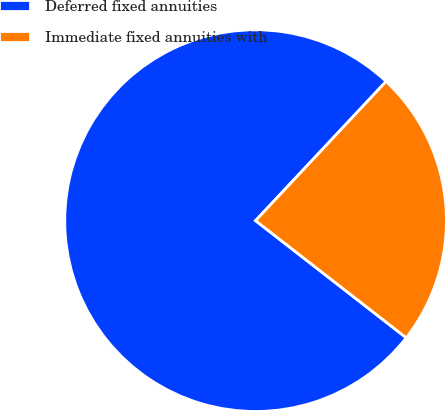<chart> <loc_0><loc_0><loc_500><loc_500><pie_chart><fcel>Deferred fixed annuities<fcel>Immediate fixed annuities with<nl><fcel>76.47%<fcel>23.53%<nl></chart> 